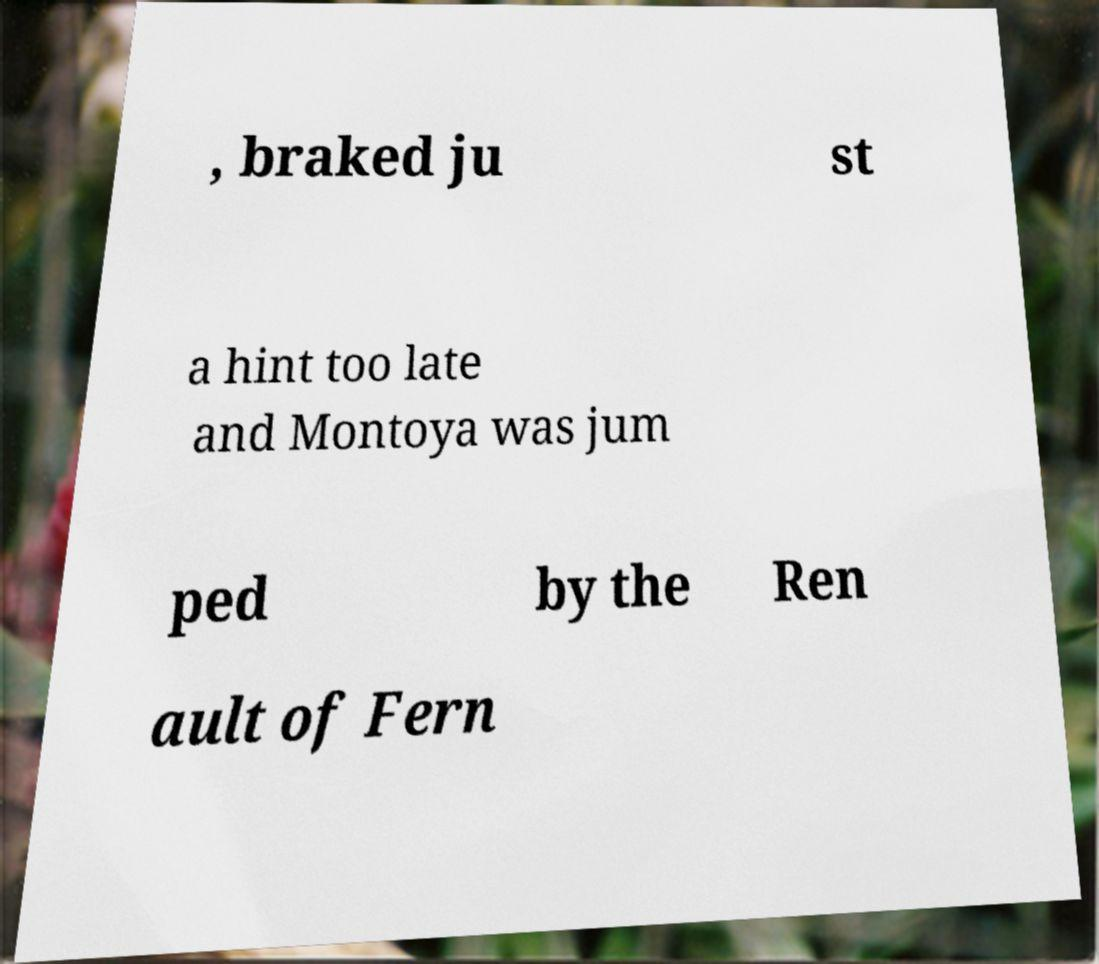Could you assist in decoding the text presented in this image and type it out clearly? , braked ju st a hint too late and Montoya was jum ped by the Ren ault of Fern 